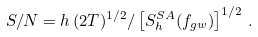<formula> <loc_0><loc_0><loc_500><loc_500>S / N = h \, ( 2 T ) ^ { 1 / 2 } / \left [ S _ { h } ^ { S A } ( f _ { g w } ) \right ] ^ { 1 / 2 } \, .</formula> 